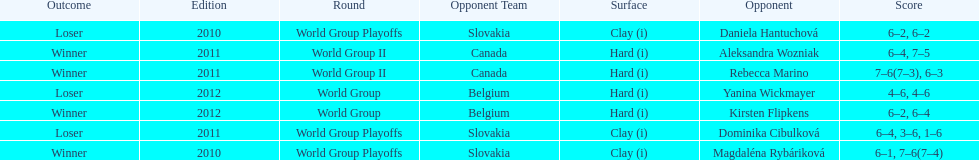What was the next game listed after the world group ii rounds? World Group Playoffs. 